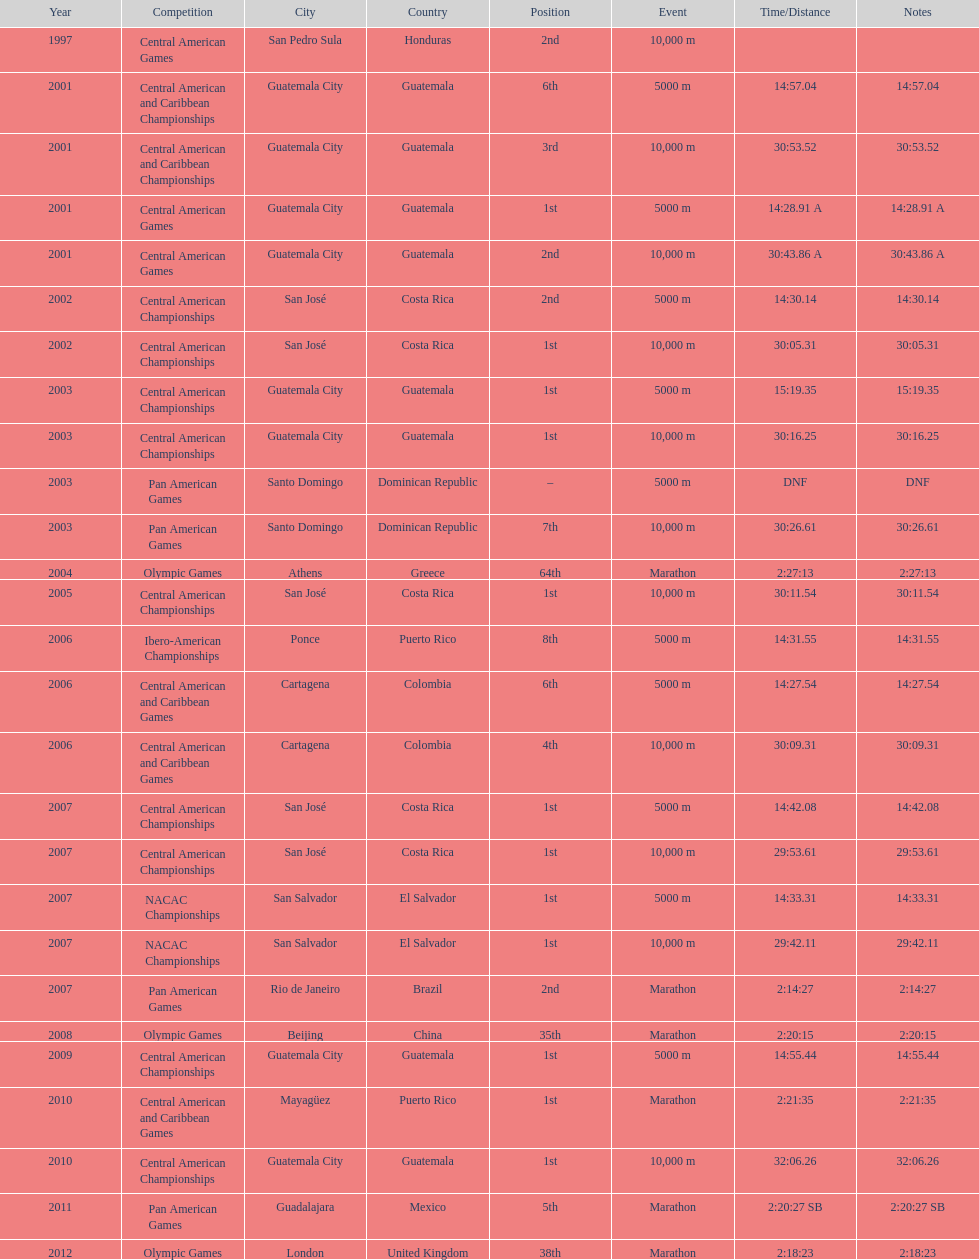How many times has the position of 1st been achieved? 12. 